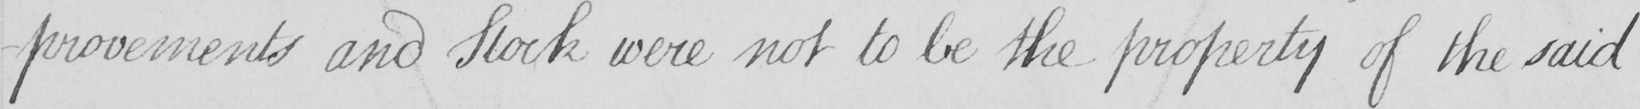Please provide the text content of this handwritten line. -provements and Stock were not to be the property of the said 